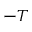Convert formula to latex. <formula><loc_0><loc_0><loc_500><loc_500>- T</formula> 